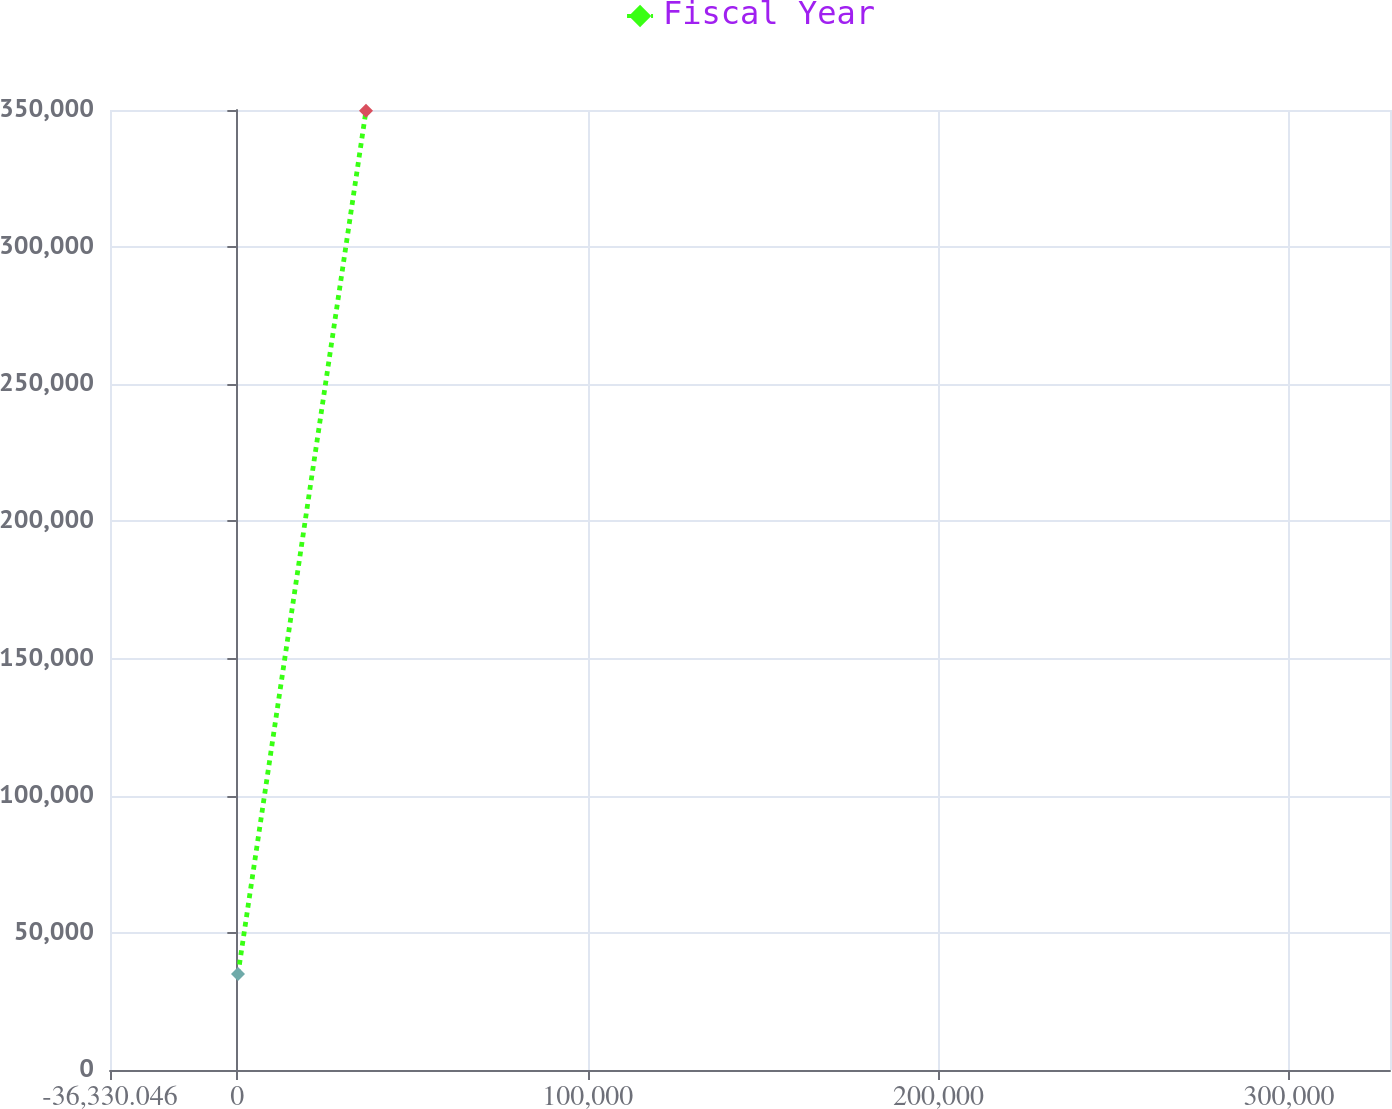<chart> <loc_0><loc_0><loc_500><loc_500><line_chart><ecel><fcel>Fiscal Year<nl><fcel>187.31<fcel>34976.4<nl><fcel>36704.7<fcel>349752<nl><fcel>365361<fcel>1.33<nl></chart> 